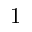Convert formula to latex. <formula><loc_0><loc_0><loc_500><loc_500>1</formula> 